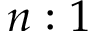<formula> <loc_0><loc_0><loc_500><loc_500>n \colon 1</formula> 